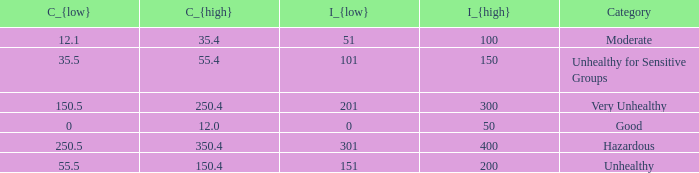What's the C_{high} when the C_{low} value is 250.5? 350.4. 